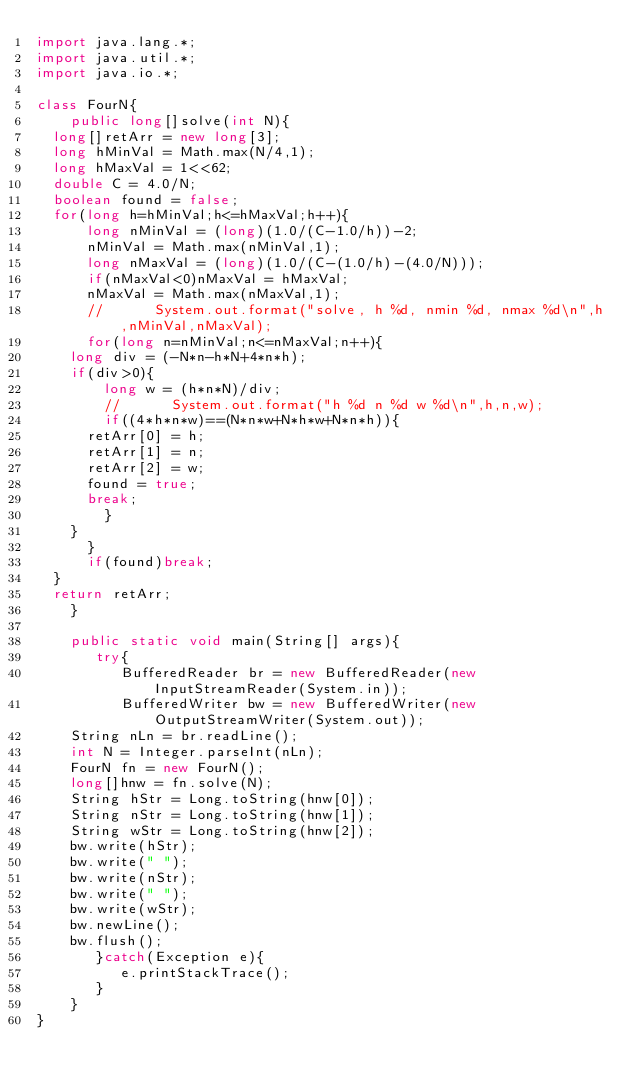Convert code to text. <code><loc_0><loc_0><loc_500><loc_500><_Java_>import java.lang.*;
import java.util.*;
import java.io.*;

class FourN{
    public long[]solve(int N){
	long[]retArr = new long[3];
	long hMinVal = Math.max(N/4,1);
	long hMaxVal = 1<<62;
	double C = 4.0/N;
	boolean found = false;
	for(long h=hMinVal;h<=hMaxVal;h++){
	    long nMinVal = (long)(1.0/(C-1.0/h))-2;
	    nMinVal = Math.max(nMinVal,1);
	    long nMaxVal = (long)(1.0/(C-(1.0/h)-(4.0/N)));
	    if(nMaxVal<0)nMaxVal = hMaxVal;
	    nMaxVal = Math.max(nMaxVal,1);
	    //	    System.out.format("solve, h %d, nmin %d, nmax %d\n",h,nMinVal,nMaxVal);
	    for(long n=nMinVal;n<=nMaxVal;n++){
		long div = (-N*n-h*N+4*n*h);
		if(div>0){
		    long w = (h*n*N)/div;
		    //	    System.out.format("h %d n %d w %d\n",h,n,w);
		    if((4*h*n*w)==(N*n*w+N*h*w+N*n*h)){
			retArr[0] = h;
			retArr[1] = n;
			retArr[2] = w;
			found = true;
			break;
		    }
		}
	    }
	    if(found)break;	    
	}
	return retArr;
    }
    
    public static void main(String[] args){
       try{
          BufferedReader br = new BufferedReader(new InputStreamReader(System.in));
          BufferedWriter bw = new BufferedWriter(new OutputStreamWriter(System.out));
	  String nLn = br.readLine();
	  int N = Integer.parseInt(nLn);
	  FourN fn = new FourN();
	  long[]hnw = fn.solve(N);
	  String hStr = Long.toString(hnw[0]);
	  String nStr = Long.toString(hnw[1]);
	  String wStr = Long.toString(hnw[2]);	  
	  bw.write(hStr);
	  bw.write(" ");
	  bw.write(nStr);
	  bw.write(" ");
	  bw.write(wStr);
	  bw.newLine();
	  bw.flush();
       }catch(Exception e){
          e.printStackTrace();
       }
    }
}	  
</code> 